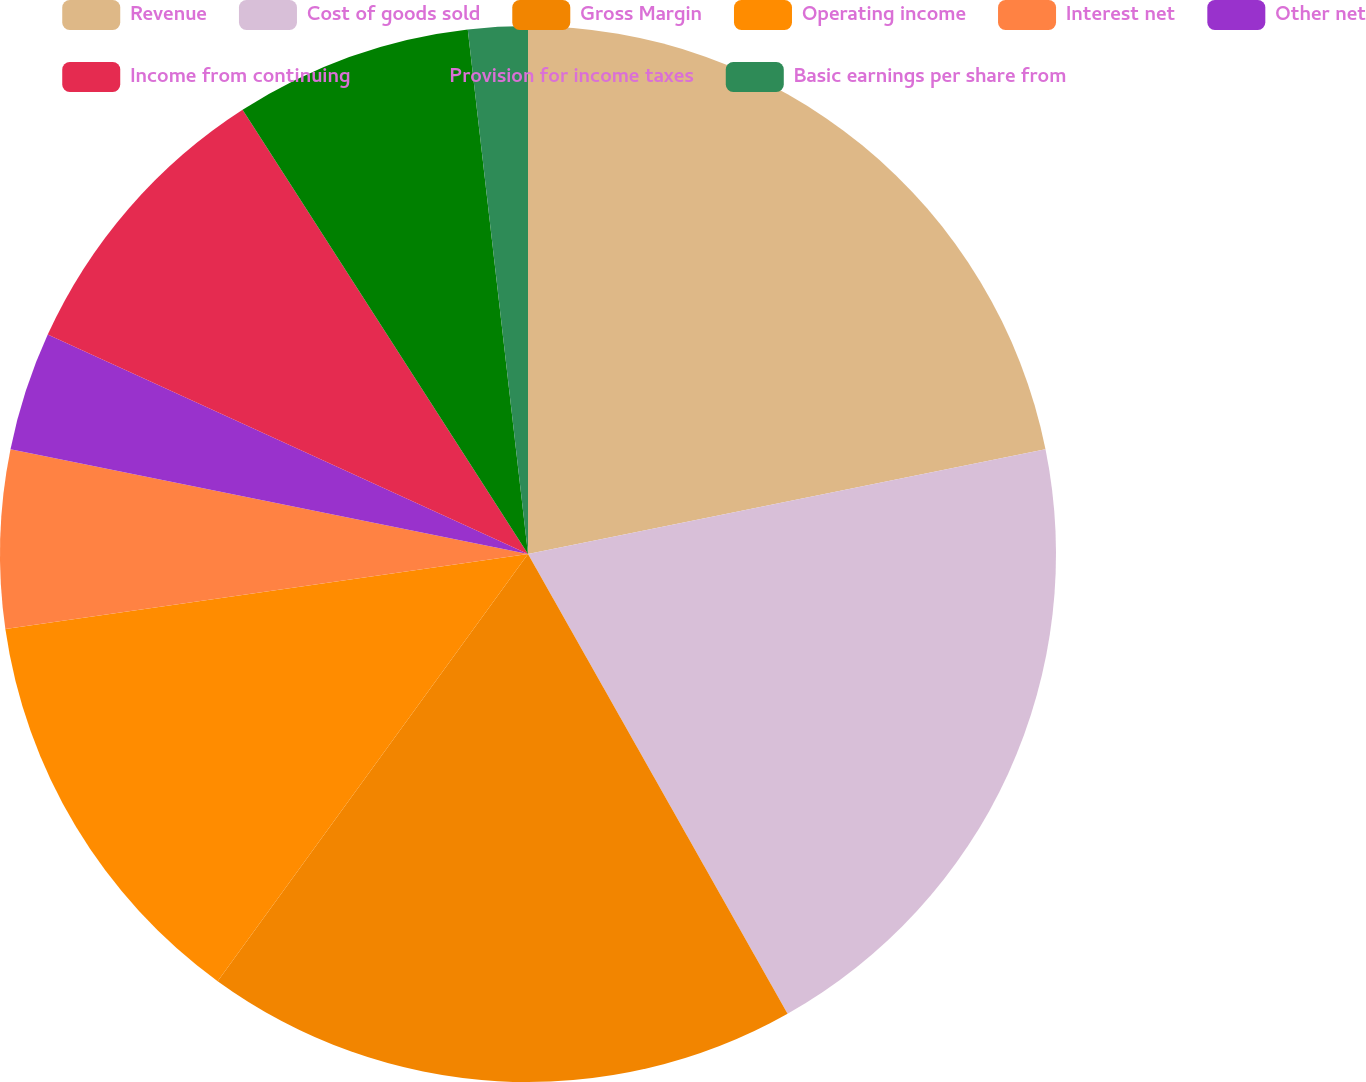Convert chart. <chart><loc_0><loc_0><loc_500><loc_500><pie_chart><fcel>Revenue<fcel>Cost of goods sold<fcel>Gross Margin<fcel>Operating income<fcel>Interest net<fcel>Other net<fcel>Income from continuing<fcel>Provision for income taxes<fcel>Basic earnings per share from<nl><fcel>21.82%<fcel>20.0%<fcel>18.18%<fcel>12.73%<fcel>5.45%<fcel>3.64%<fcel>9.09%<fcel>7.27%<fcel>1.82%<nl></chart> 